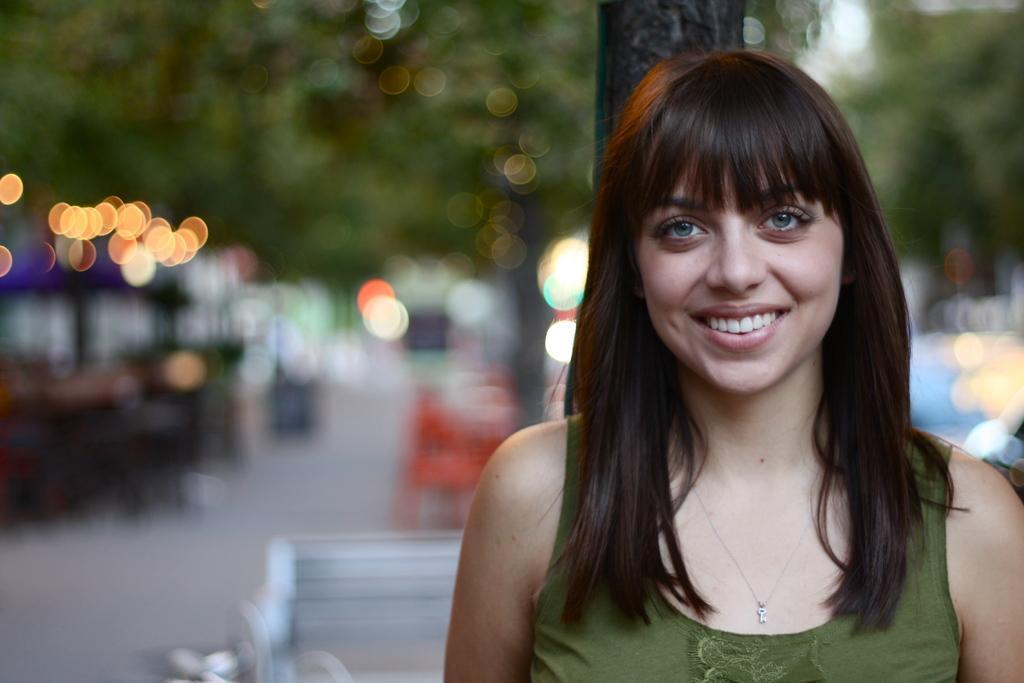How would you summarize this image in a sentence or two? In this image we can see a lady. There are many trees in the image. There is a bench in the image. 